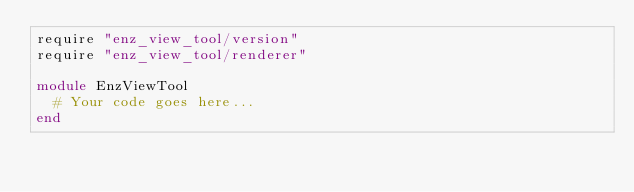<code> <loc_0><loc_0><loc_500><loc_500><_Ruby_>require "enz_view_tool/version"
require "enz_view_tool/renderer"

module EnzViewTool
  # Your code goes here...
end
</code> 